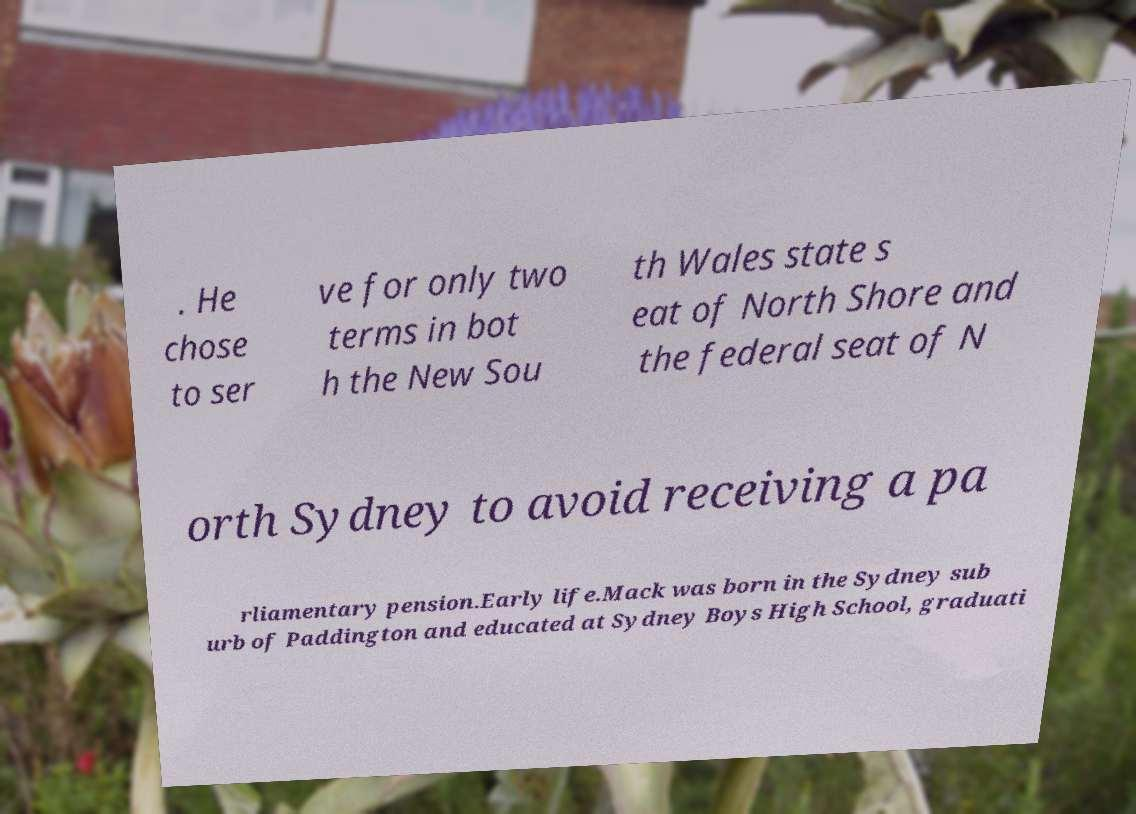I need the written content from this picture converted into text. Can you do that? . He chose to ser ve for only two terms in bot h the New Sou th Wales state s eat of North Shore and the federal seat of N orth Sydney to avoid receiving a pa rliamentary pension.Early life.Mack was born in the Sydney sub urb of Paddington and educated at Sydney Boys High School, graduati 